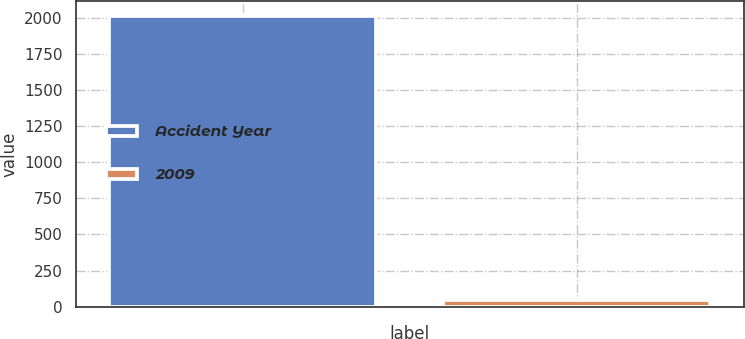<chart> <loc_0><loc_0><loc_500><loc_500><bar_chart><fcel>Accident Year<fcel>2009<nl><fcel>2015<fcel>44<nl></chart> 